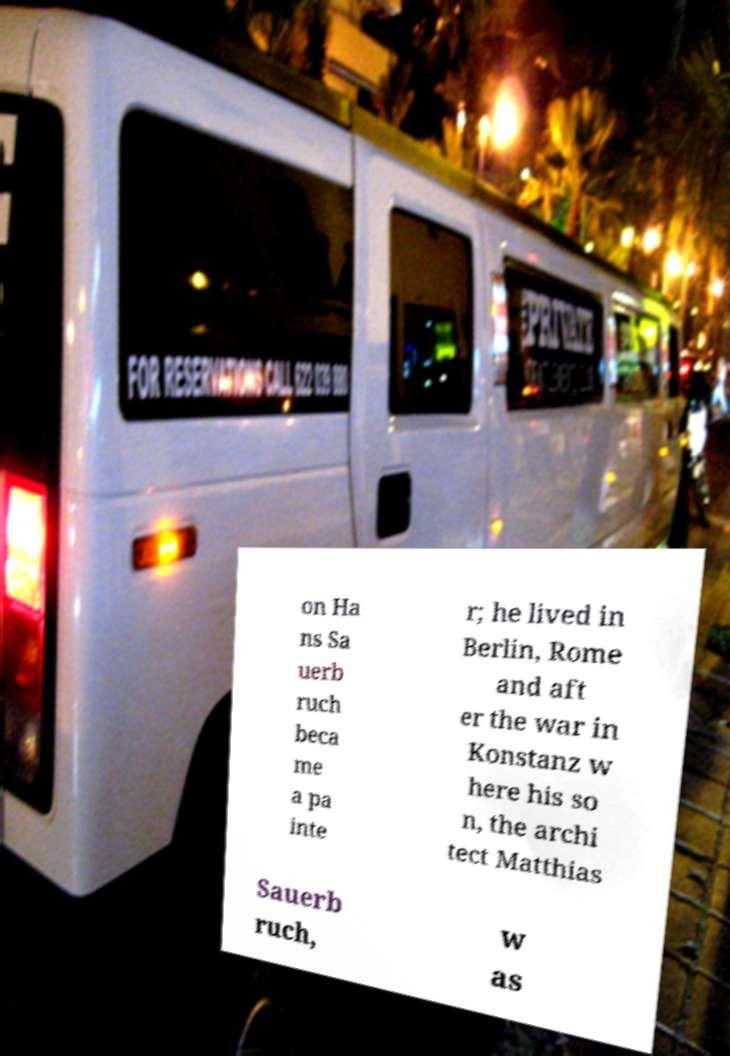I need the written content from this picture converted into text. Can you do that? on Ha ns Sa uerb ruch beca me a pa inte r; he lived in Berlin, Rome and aft er the war in Konstanz w here his so n, the archi tect Matthias Sauerb ruch, w as 